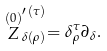<formula> <loc_0><loc_0><loc_500><loc_500>\stackrel { ( 0 ) } { Z } _ { \delta ( \rho ) } ^ { \prime \, ( \tau ) } = \delta _ { \rho } ^ { \tau } \partial _ { \delta } .</formula> 